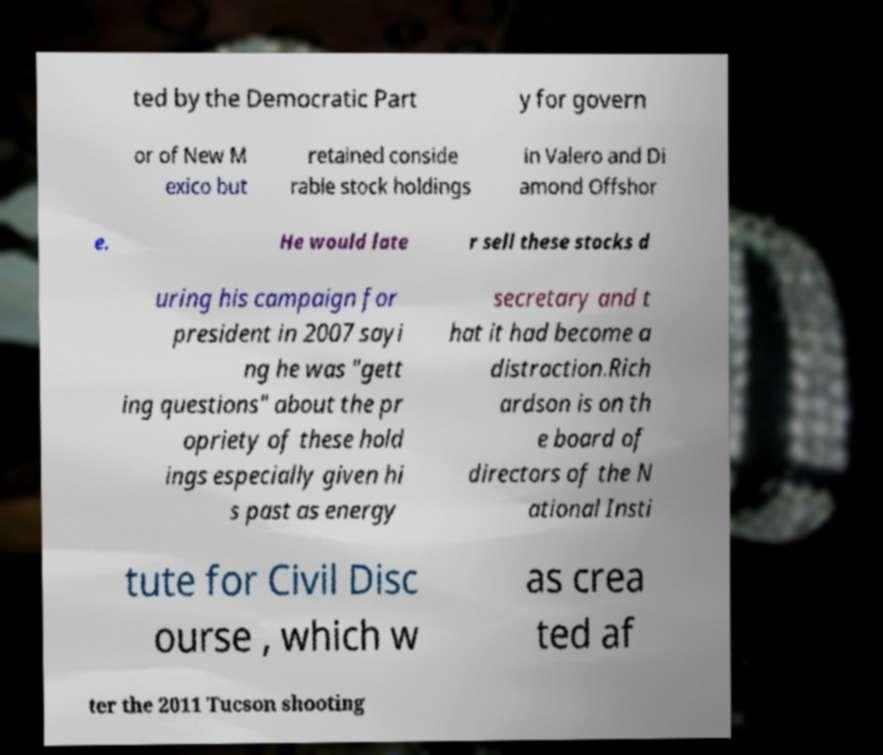Could you extract and type out the text from this image? ted by the Democratic Part y for govern or of New M exico but retained conside rable stock holdings in Valero and Di amond Offshor e. He would late r sell these stocks d uring his campaign for president in 2007 sayi ng he was "gett ing questions" about the pr opriety of these hold ings especially given hi s past as energy secretary and t hat it had become a distraction.Rich ardson is on th e board of directors of the N ational Insti tute for Civil Disc ourse , which w as crea ted af ter the 2011 Tucson shooting 